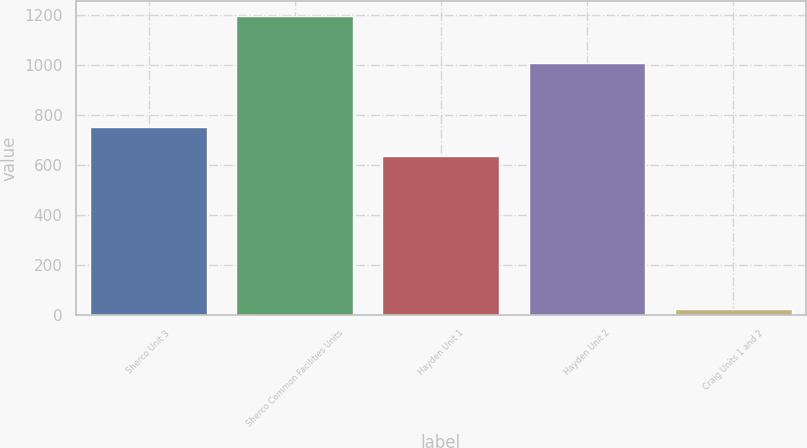Convert chart to OTSL. <chart><loc_0><loc_0><loc_500><loc_500><bar_chart><fcel>Sherco Unit 3<fcel>Sherco Common Facilities Units<fcel>Hayden Unit 1<fcel>Hayden Unit 2<fcel>Craig Units 1 and 2<nl><fcel>752.2<fcel>1196<fcel>635<fcel>1006<fcel>24<nl></chart> 